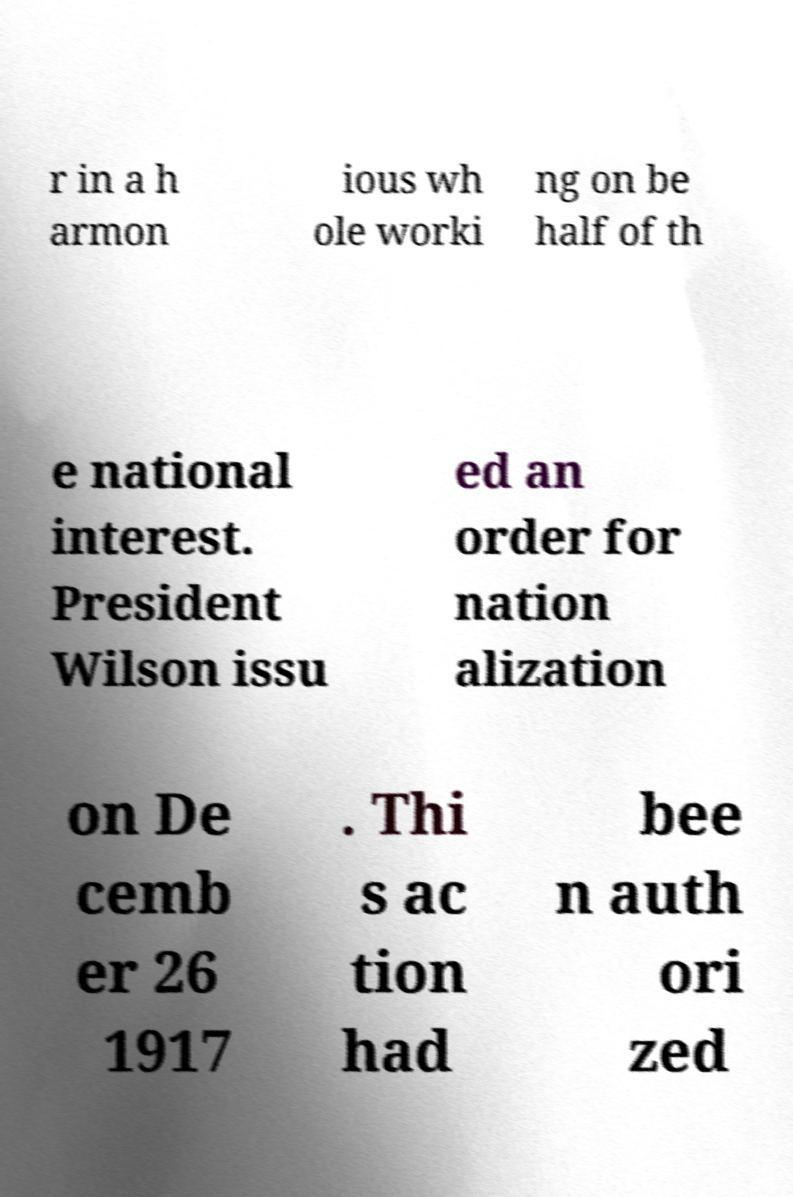Can you read and provide the text displayed in the image?This photo seems to have some interesting text. Can you extract and type it out for me? r in a h armon ious wh ole worki ng on be half of th e national interest. President Wilson issu ed an order for nation alization on De cemb er 26 1917 . Thi s ac tion had bee n auth ori zed 